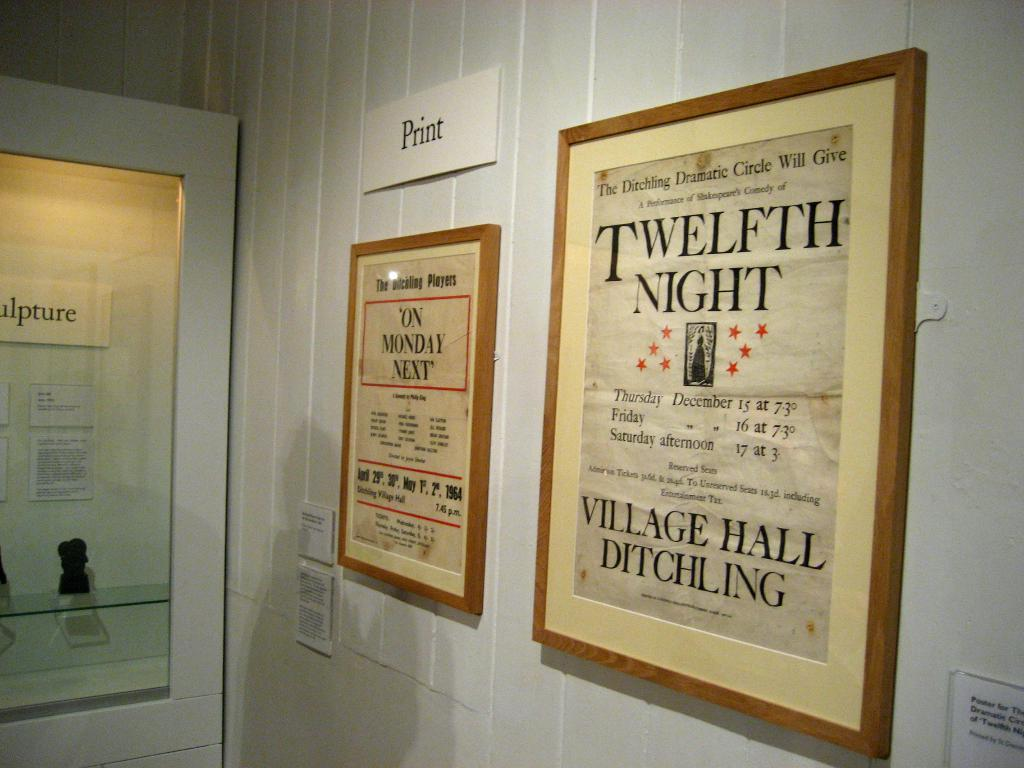Provide a one-sentence caption for the provided image. A poster hanging on the wall advertising Shakespeare's Twelfth Night. 